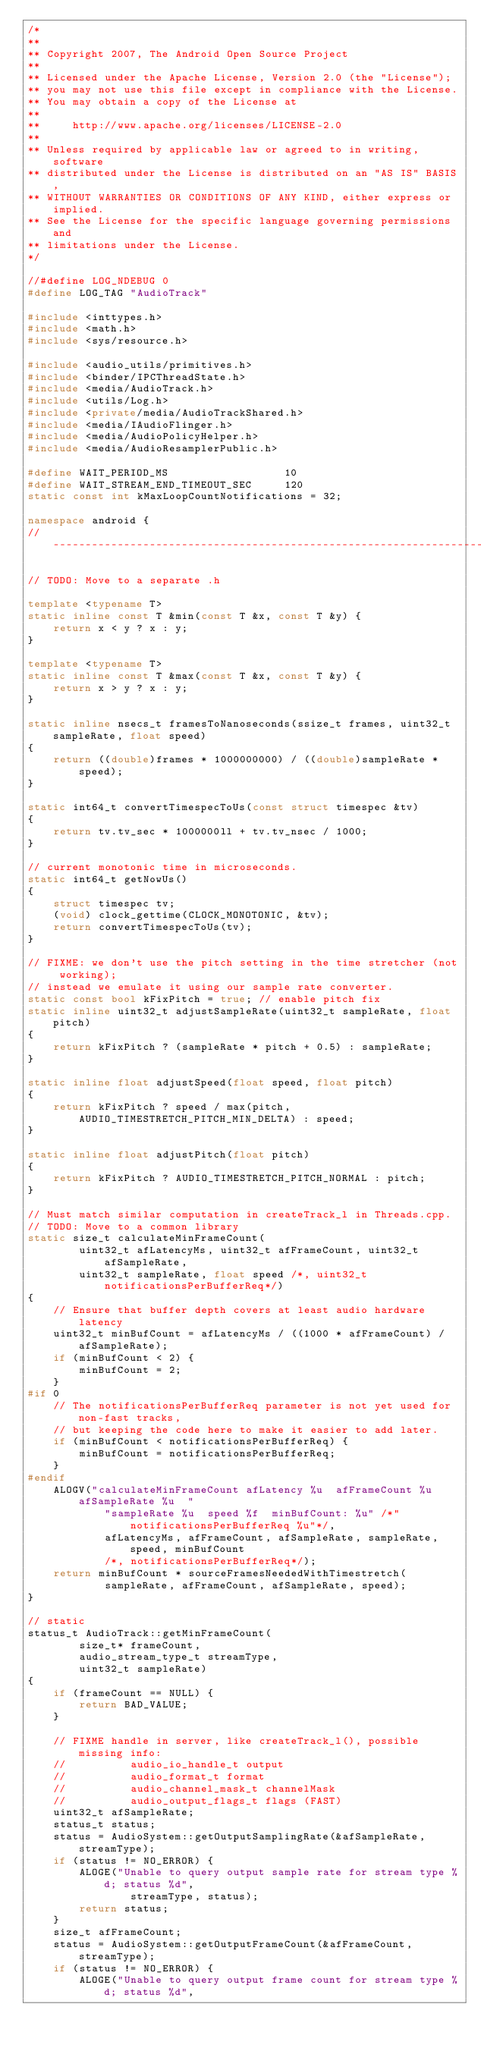Convert code to text. <code><loc_0><loc_0><loc_500><loc_500><_C++_>/*
**
** Copyright 2007, The Android Open Source Project
**
** Licensed under the Apache License, Version 2.0 (the "License");
** you may not use this file except in compliance with the License.
** You may obtain a copy of the License at
**
**     http://www.apache.org/licenses/LICENSE-2.0
**
** Unless required by applicable law or agreed to in writing, software
** distributed under the License is distributed on an "AS IS" BASIS,
** WITHOUT WARRANTIES OR CONDITIONS OF ANY KIND, either express or implied.
** See the License for the specific language governing permissions and
** limitations under the License.
*/

//#define LOG_NDEBUG 0
#define LOG_TAG "AudioTrack"

#include <inttypes.h>
#include <math.h>
#include <sys/resource.h>

#include <audio_utils/primitives.h>
#include <binder/IPCThreadState.h>
#include <media/AudioTrack.h>
#include <utils/Log.h>
#include <private/media/AudioTrackShared.h>
#include <media/IAudioFlinger.h>
#include <media/AudioPolicyHelper.h>
#include <media/AudioResamplerPublic.h>

#define WAIT_PERIOD_MS                  10
#define WAIT_STREAM_END_TIMEOUT_SEC     120
static const int kMaxLoopCountNotifications = 32;

namespace android {
// ---------------------------------------------------------------------------

// TODO: Move to a separate .h

template <typename T>
static inline const T &min(const T &x, const T &y) {
    return x < y ? x : y;
}

template <typename T>
static inline const T &max(const T &x, const T &y) {
    return x > y ? x : y;
}

static inline nsecs_t framesToNanoseconds(ssize_t frames, uint32_t sampleRate, float speed)
{
    return ((double)frames * 1000000000) / ((double)sampleRate * speed);
}

static int64_t convertTimespecToUs(const struct timespec &tv)
{
    return tv.tv_sec * 1000000ll + tv.tv_nsec / 1000;
}

// current monotonic time in microseconds.
static int64_t getNowUs()
{
    struct timespec tv;
    (void) clock_gettime(CLOCK_MONOTONIC, &tv);
    return convertTimespecToUs(tv);
}

// FIXME: we don't use the pitch setting in the time stretcher (not working);
// instead we emulate it using our sample rate converter.
static const bool kFixPitch = true; // enable pitch fix
static inline uint32_t adjustSampleRate(uint32_t sampleRate, float pitch)
{
    return kFixPitch ? (sampleRate * pitch + 0.5) : sampleRate;
}

static inline float adjustSpeed(float speed, float pitch)
{
    return kFixPitch ? speed / max(pitch, AUDIO_TIMESTRETCH_PITCH_MIN_DELTA) : speed;
}

static inline float adjustPitch(float pitch)
{
    return kFixPitch ? AUDIO_TIMESTRETCH_PITCH_NORMAL : pitch;
}

// Must match similar computation in createTrack_l in Threads.cpp.
// TODO: Move to a common library
static size_t calculateMinFrameCount(
        uint32_t afLatencyMs, uint32_t afFrameCount, uint32_t afSampleRate,
        uint32_t sampleRate, float speed /*, uint32_t notificationsPerBufferReq*/)
{
    // Ensure that buffer depth covers at least audio hardware latency
    uint32_t minBufCount = afLatencyMs / ((1000 * afFrameCount) / afSampleRate);
    if (minBufCount < 2) {
        minBufCount = 2;
    }
#if 0
    // The notificationsPerBufferReq parameter is not yet used for non-fast tracks,
    // but keeping the code here to make it easier to add later.
    if (minBufCount < notificationsPerBufferReq) {
        minBufCount = notificationsPerBufferReq;
    }
#endif
    ALOGV("calculateMinFrameCount afLatency %u  afFrameCount %u  afSampleRate %u  "
            "sampleRate %u  speed %f  minBufCount: %u" /*"  notificationsPerBufferReq %u"*/,
            afLatencyMs, afFrameCount, afSampleRate, sampleRate, speed, minBufCount
            /*, notificationsPerBufferReq*/);
    return minBufCount * sourceFramesNeededWithTimestretch(
            sampleRate, afFrameCount, afSampleRate, speed);
}

// static
status_t AudioTrack::getMinFrameCount(
        size_t* frameCount,
        audio_stream_type_t streamType,
        uint32_t sampleRate)
{
    if (frameCount == NULL) {
        return BAD_VALUE;
    }

    // FIXME handle in server, like createTrack_l(), possible missing info:
    //          audio_io_handle_t output
    //          audio_format_t format
    //          audio_channel_mask_t channelMask
    //          audio_output_flags_t flags (FAST)
    uint32_t afSampleRate;
    status_t status;
    status = AudioSystem::getOutputSamplingRate(&afSampleRate, streamType);
    if (status != NO_ERROR) {
        ALOGE("Unable to query output sample rate for stream type %d; status %d",
                streamType, status);
        return status;
    }
    size_t afFrameCount;
    status = AudioSystem::getOutputFrameCount(&afFrameCount, streamType);
    if (status != NO_ERROR) {
        ALOGE("Unable to query output frame count for stream type %d; status %d",</code> 